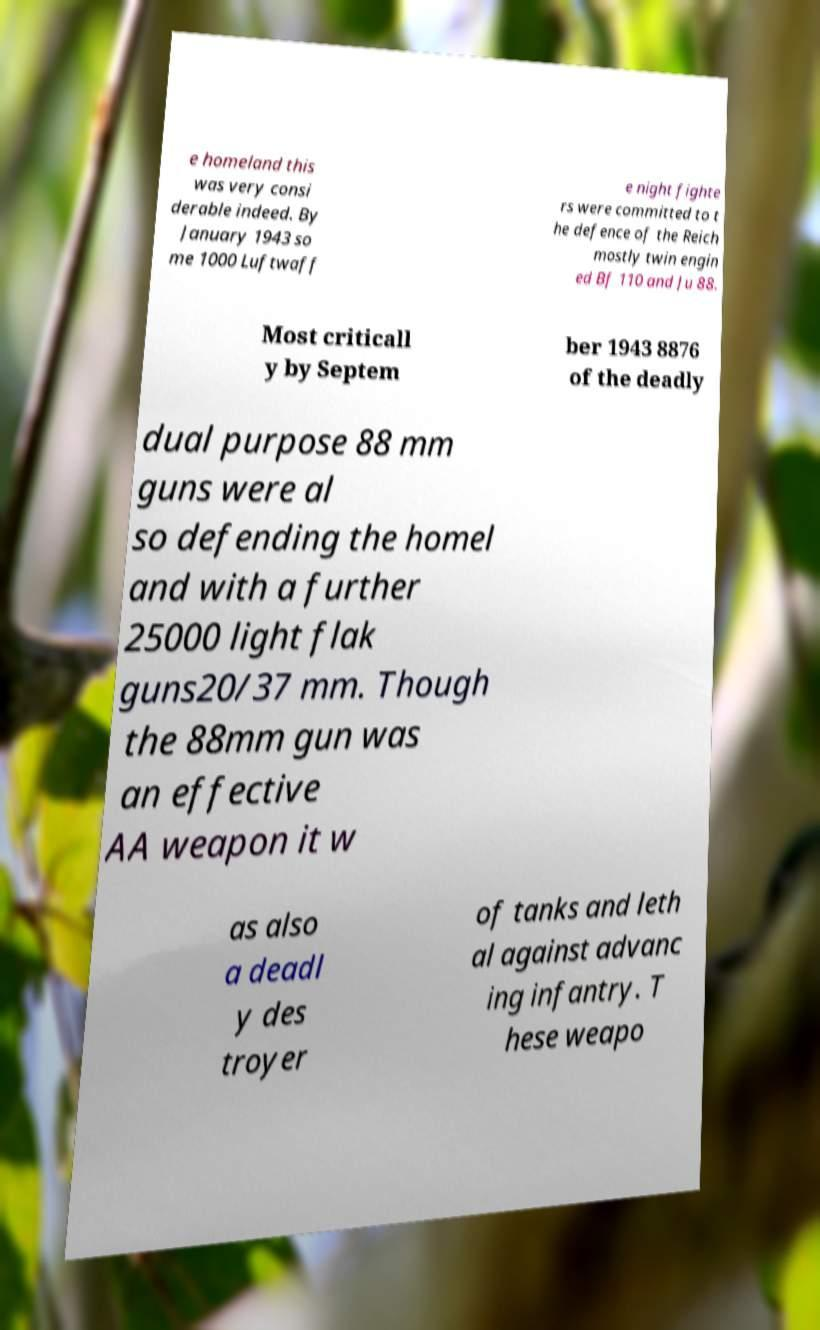For documentation purposes, I need the text within this image transcribed. Could you provide that? e homeland this was very consi derable indeed. By January 1943 so me 1000 Luftwaff e night fighte rs were committed to t he defence of the Reich mostly twin engin ed Bf 110 and Ju 88. Most criticall y by Septem ber 1943 8876 of the deadly dual purpose 88 mm guns were al so defending the homel and with a further 25000 light flak guns20/37 mm. Though the 88mm gun was an effective AA weapon it w as also a deadl y des troyer of tanks and leth al against advanc ing infantry. T hese weapo 